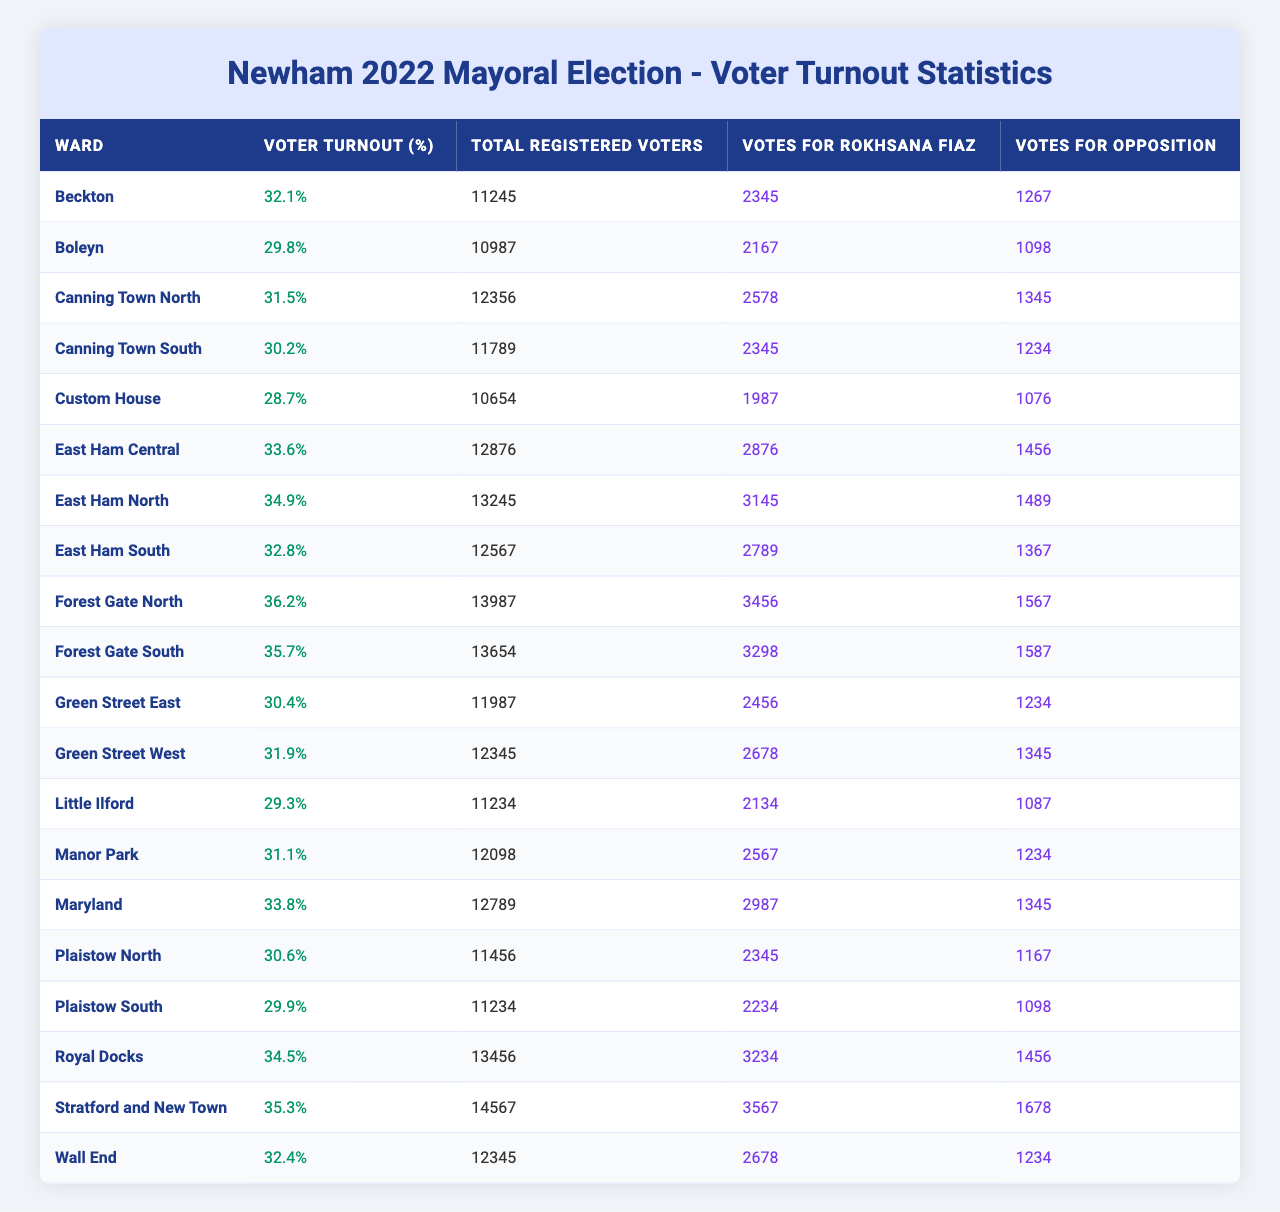What was the voter turnout percentage in the Beckton ward? The voter turnout percentage for the Beckton ward is listed in the table and is 32.1%.
Answer: 32.1% Which ward had the highest voter turnout percentage? By scanning the voter turnout percentages in the table, the highest value is 36.2% for the East Ham South ward.
Answer: East Ham South How many total registered voters were there in the Boleyn ward? The number of total registered voters for the Boleyn ward is directly provided in the table as 10,987.
Answer: 10,987 What is the total number of votes received by Rokhsana Fiaz in the East Ham North ward? The votes for Rokhsana Fiaz in the East Ham North ward can be found in the table, which shows 3,145 votes.
Answer: 3,145 Which ward had more votes for Rokhsana Fiaz than opposition? Examining the votes for both Rokhsana Fiaz and opposition in the table, the Little Ilford ward has 2,134 votes for Fiaz and 1,087 for opposition; hence, it qualifies.
Answer: Little Ilford What is the average voter turnout percentage across all wards? To determine the average, sum all voter turnout percentages (32.1 + 29.8 + ... + 32.4) and divide by the number of wards (20). The total sum is 652.2, so the average is 652.2/20 = 32.61%.
Answer: 32.61% In how many wards did Rokhsana Fiaz receive more than 2,500 votes? By counting the number of wards where votes for Rokhsana Fiaz exceed 2,500 (Beckton, Canning Town North, East Ham Central, East Ham North, Royal Docks, Stratford and New Town, Wall End), we find she received more than 2,500 votes in 7 wards.
Answer: 7 Is the voter turnout in Stratford and New Town higher or lower than the average turnout for all wards? The voter turnout in Stratford and New Town is 35.3%. Since the average voter turnout is 32.61%, we can conclude that 35.3% is higher.
Answer: Higher What is the combined total of votes for Rokhsana Fiaz and opposition in the Canning Town South ward? Adding the votes for both candidates in the Canning Town South ward gives 2,345 (Rokhsana Fiaz) + 1,234 (opposition) = 3,579.
Answer: 3,579 Which two wards had the lowest total registered voters? Checking the total registered voters in the table, Custom House has 10,654 and Boleyn has 10,987; none are lower than these two.
Answer: Custom House, Boleyn 